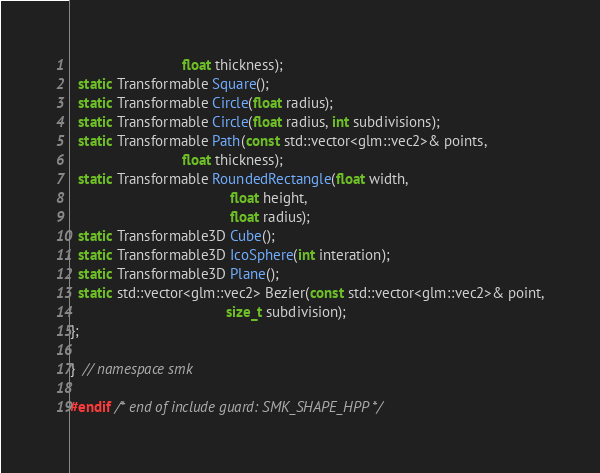Convert code to text. <code><loc_0><loc_0><loc_500><loc_500><_C++_>                            float thickness);
  static Transformable Square();
  static Transformable Circle(float radius);
  static Transformable Circle(float radius, int subdivisions);
  static Transformable Path(const std::vector<glm::vec2>& points,
                            float thickness);
  static Transformable RoundedRectangle(float width,
                                        float height,
                                        float radius);
  static Transformable3D Cube();
  static Transformable3D IcoSphere(int interation);
  static Transformable3D Plane();
  static std::vector<glm::vec2> Bezier(const std::vector<glm::vec2>& point,
                                       size_t subdivision);
};

}  // namespace smk

#endif /* end of include guard: SMK_SHAPE_HPP */
</code> 